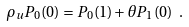<formula> <loc_0><loc_0><loc_500><loc_500>\rho _ { u } P _ { 0 } ( 0 ) = P _ { 0 } ( 1 ) + \theta P _ { 1 } ( 0 ) \ .</formula> 